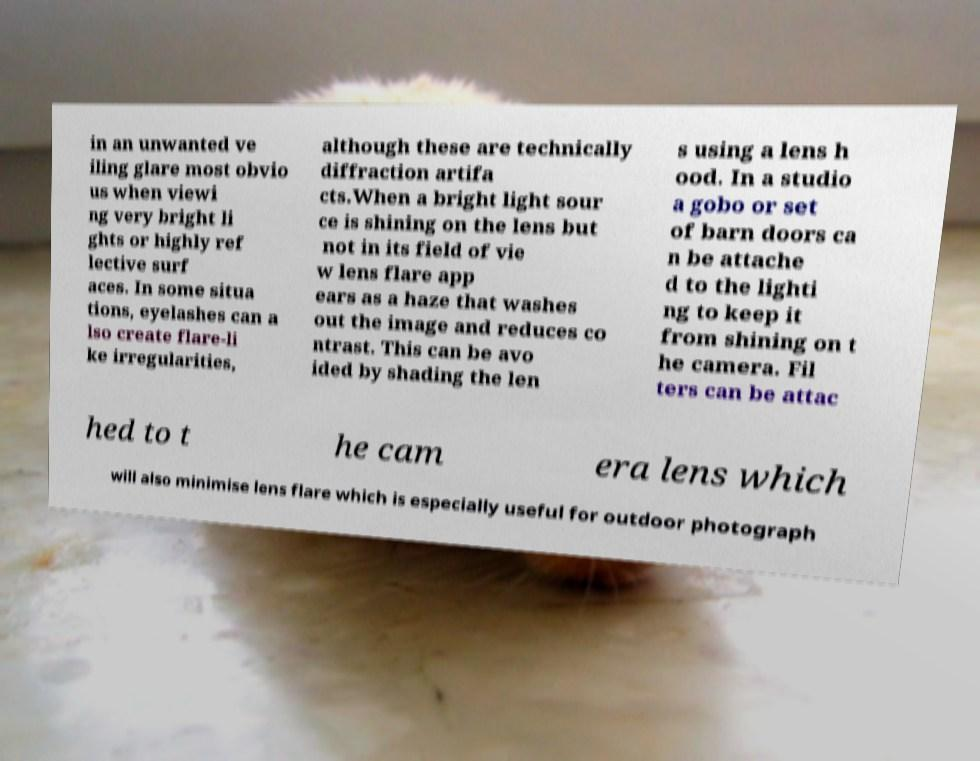Can you accurately transcribe the text from the provided image for me? in an unwanted ve iling glare most obvio us when viewi ng very bright li ghts or highly ref lective surf aces. In some situa tions, eyelashes can a lso create flare-li ke irregularities, although these are technically diffraction artifa cts.When a bright light sour ce is shining on the lens but not in its field of vie w lens flare app ears as a haze that washes out the image and reduces co ntrast. This can be avo ided by shading the len s using a lens h ood. In a studio a gobo or set of barn doors ca n be attache d to the lighti ng to keep it from shining on t he camera. Fil ters can be attac hed to t he cam era lens which will also minimise lens flare which is especially useful for outdoor photograph 